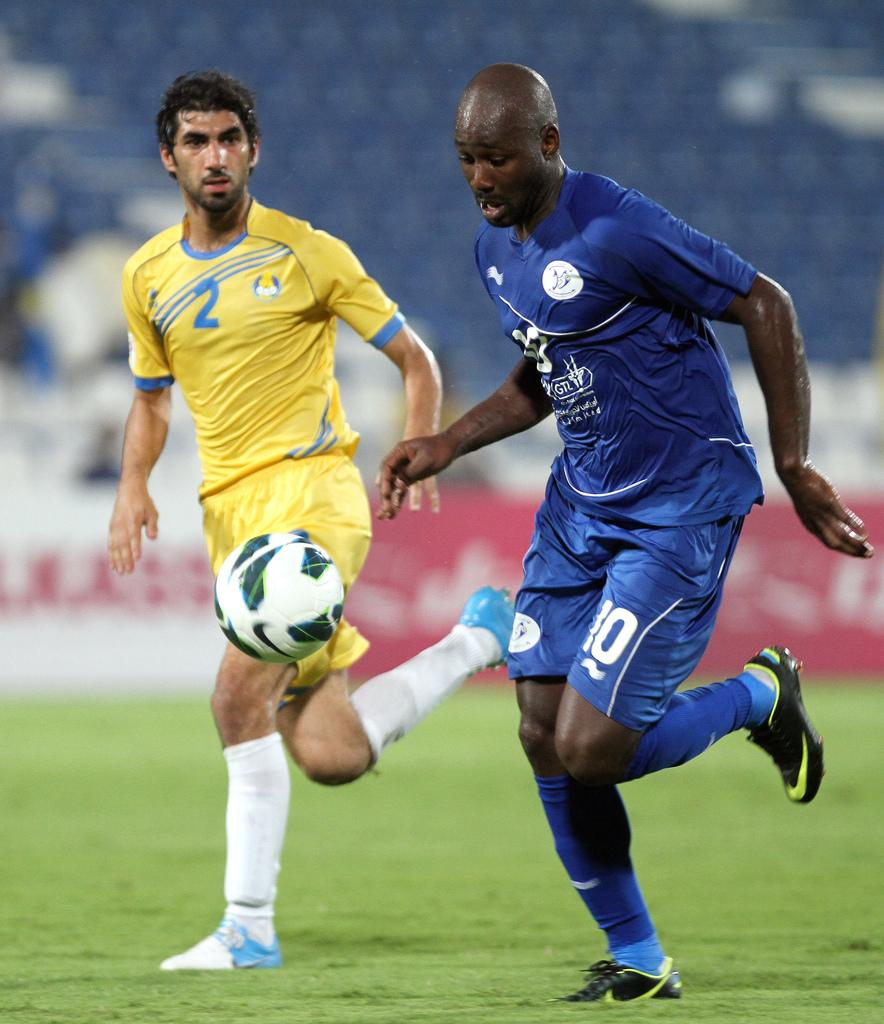How many people are in the image? There are two persons in the image. What are the two persons doing in the image? The two persons are playing football. What type of surface is the football game being played on? There is grass on the ground in the image. Can you describe the background of the image? The background of the image appears blurry. What type of berry can be seen on the wrist of one of the players in the image? There is no berry present on the wrist of any player in the image. 